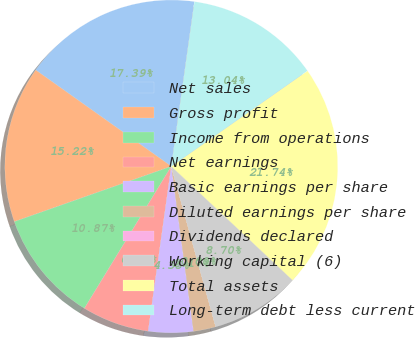<chart> <loc_0><loc_0><loc_500><loc_500><pie_chart><fcel>Net sales<fcel>Gross profit<fcel>Income from operations<fcel>Net earnings<fcel>Basic earnings per share<fcel>Diluted earnings per share<fcel>Dividends declared<fcel>Working capital (6)<fcel>Total assets<fcel>Long-term debt less current<nl><fcel>17.39%<fcel>15.22%<fcel>10.87%<fcel>6.52%<fcel>4.35%<fcel>2.17%<fcel>0.0%<fcel>8.7%<fcel>21.74%<fcel>13.04%<nl></chart> 